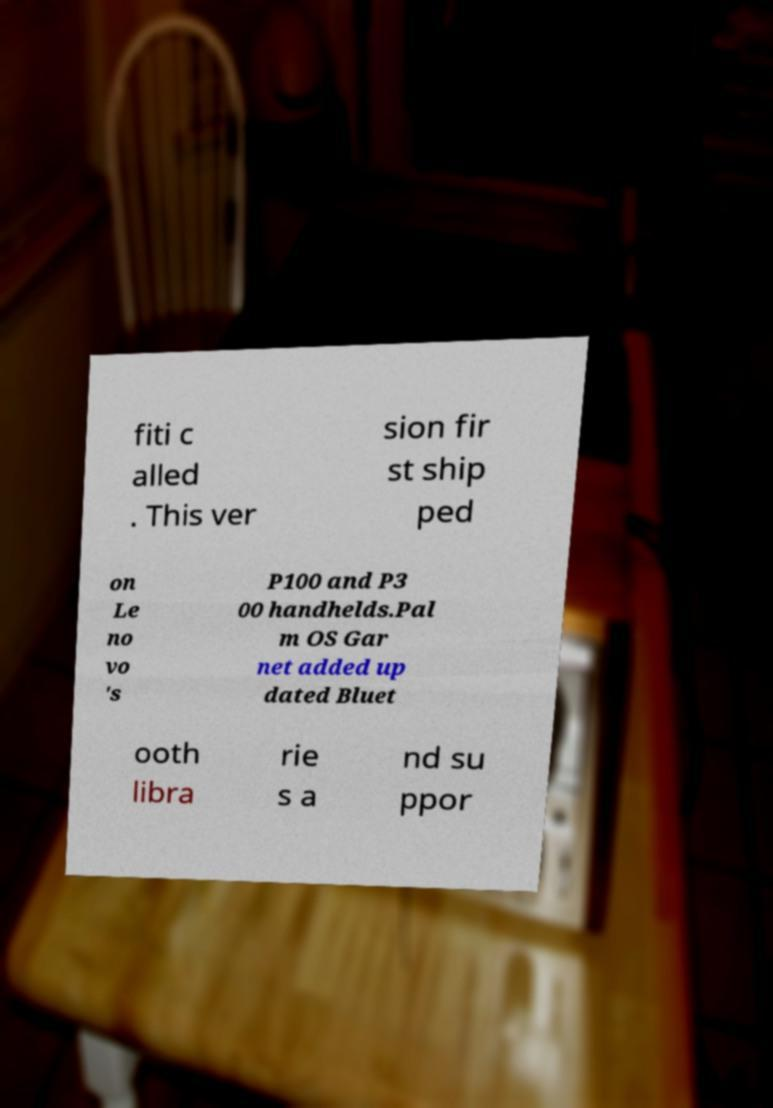Could you assist in decoding the text presented in this image and type it out clearly? fiti c alled . This ver sion fir st ship ped on Le no vo 's P100 and P3 00 handhelds.Pal m OS Gar net added up dated Bluet ooth libra rie s a nd su ppor 